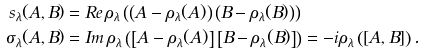Convert formula to latex. <formula><loc_0><loc_0><loc_500><loc_500>s _ { \lambda } ( A , B ) & = R e \, \rho _ { \lambda } \left ( \left ( A - \rho _ { \lambda } ( A ) \right ) \left ( B - \rho _ { \lambda } ( B ) \right ) \right ) \\ \sigma _ { \lambda } ( A , B ) & = I m \, \rho _ { \lambda } \left ( \left [ A - \rho _ { \lambda } ( A ) \right ] \left [ B - \rho _ { \lambda } ( B ) \right ] \right ) = - i \rho _ { \lambda } \left ( [ A , B ] \right ) .</formula> 